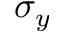Convert formula to latex. <formula><loc_0><loc_0><loc_500><loc_500>\sigma _ { y }</formula> 